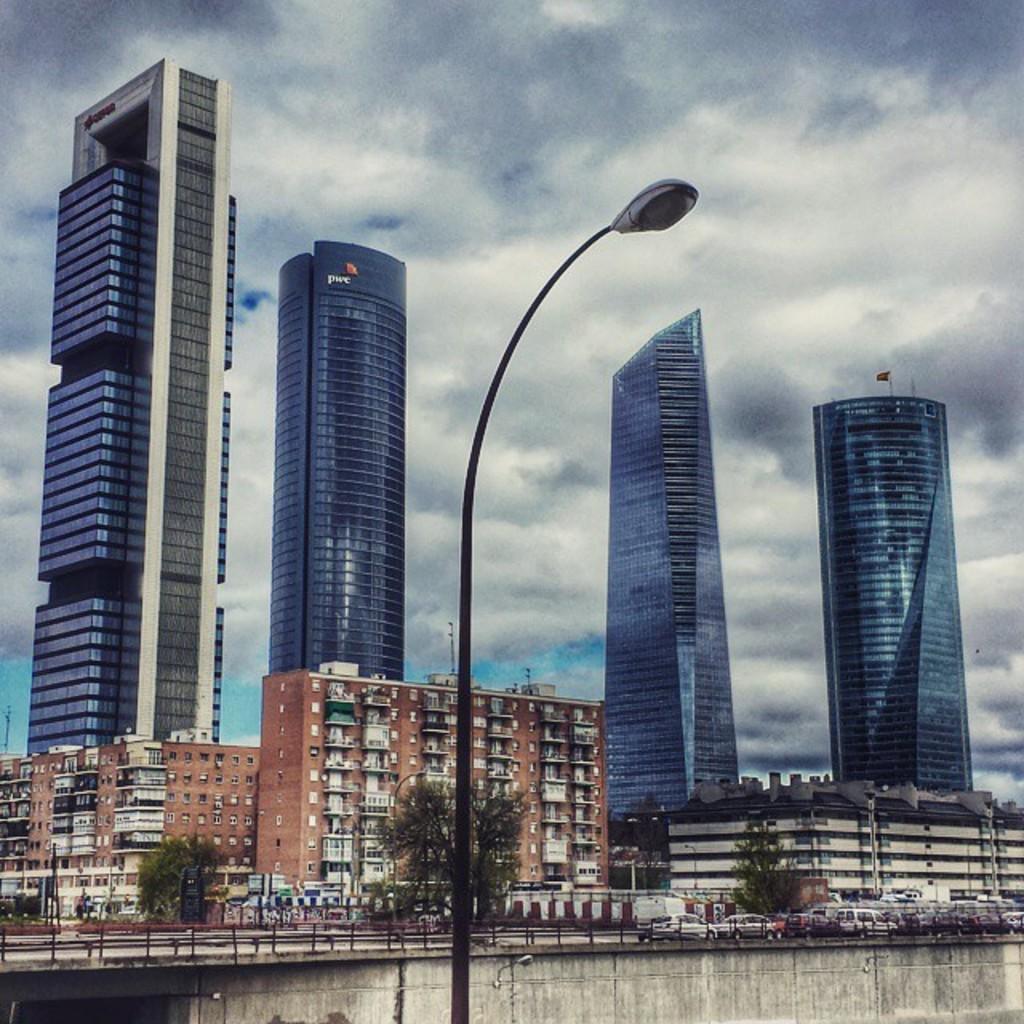Can you describe this image briefly? In this image I can see the light pole. In the background I can see few vehicles on the road, few buildings and the sky is blue and white color. 